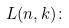Convert formula to latex. <formula><loc_0><loc_0><loc_500><loc_500>L ( n , k ) \colon</formula> 